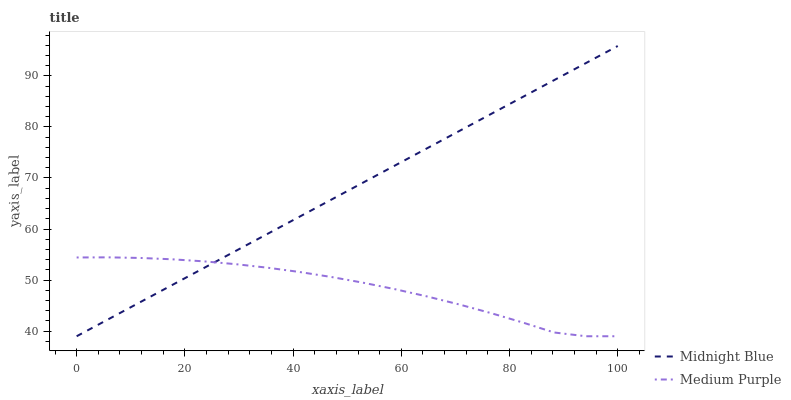Does Medium Purple have the minimum area under the curve?
Answer yes or no. Yes. Does Midnight Blue have the maximum area under the curve?
Answer yes or no. Yes. Does Midnight Blue have the minimum area under the curve?
Answer yes or no. No. Is Midnight Blue the smoothest?
Answer yes or no. Yes. Is Medium Purple the roughest?
Answer yes or no. Yes. Is Midnight Blue the roughest?
Answer yes or no. No. Does Medium Purple have the lowest value?
Answer yes or no. Yes. Does Midnight Blue have the highest value?
Answer yes or no. Yes. Does Medium Purple intersect Midnight Blue?
Answer yes or no. Yes. Is Medium Purple less than Midnight Blue?
Answer yes or no. No. Is Medium Purple greater than Midnight Blue?
Answer yes or no. No. 